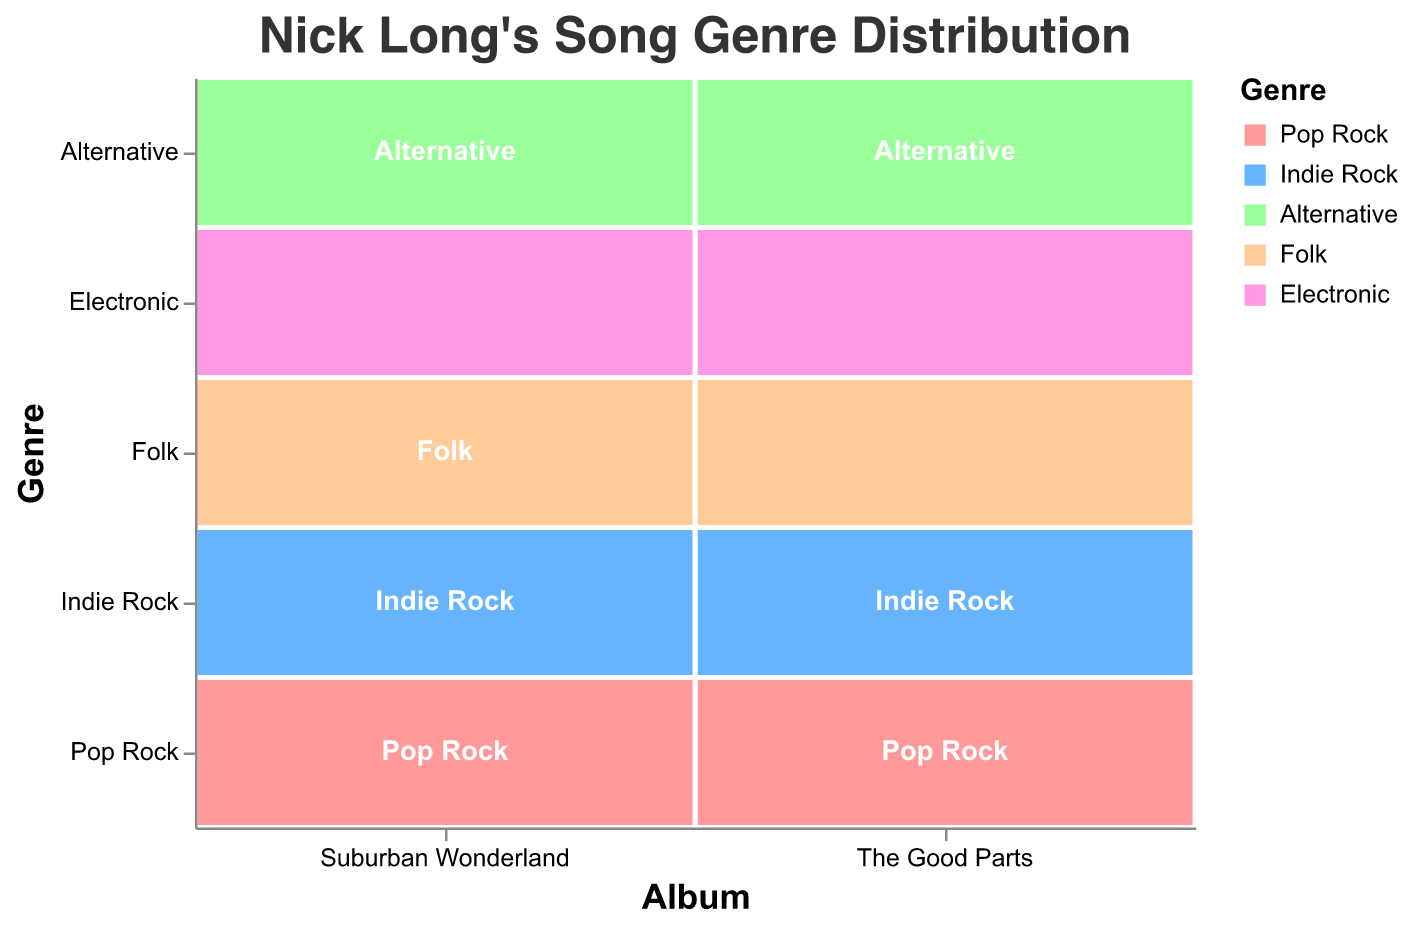What is the title of the figure? The title is text displayed at the top of the figure. In this case, it's "Nick Long's Song Genre Distribution".
Answer: Nick Long's Song Genre Distribution How many genres are represented in 'The Good Parts' album? Count the distinct genres listed under the 'Album' category for 'The Good Parts'. These genres are Pop Rock, Indie Rock, Alternative, Folk, and Electronic.
Answer: 5 Which genre has the highest count in 'Suburban Wonderland'? Look for the genre with the largest rectangle in terms of area in 'Suburban Wonderland'. 'Pop Rock' has the count of 6 which is the highest.
Answer: Pop Rock What is the total count of Folk songs across both albums? Add the Folk counts from both albums: 2 (The Good Parts) + 3 (Suburban Wonderland).
Answer: 5 Does 'Alternative' have more songs in 'The Good Parts' or 'Suburban Wonderland'? Compare the counts of 'Alternative' in both albums. 'The Good Parts' has 3 and 'Suburban Wonderland' has 5, so 'Suburban Wonderland' has more.
Answer: Suburban Wonderland What genre is least represented in both albums combined? Sum the counts for each genre across both albums and look for the smallest total. 'Electronic' has 1 (The Good Parts) + 2 (Suburban Wonderland) = 3, which is the smallest.
Answer: Electronic How many songs in total are there in 'The Good Parts'? Sum the counts for all genres in 'The Good Parts': 7 (Pop Rock) + 5 (Indie Rock) + 3 (Alternative) + 2 (Folk) + 1 (Electronic).
Answer: 18 What is the ratio of 'Pop Rock' songs in 'The Good Parts' to 'Suburban Wonderland'? Divide the count of 'Pop Rock' in 'The Good Parts' by the count in 'Suburban Wonderland': 7 / 6.
Answer: 7:6 Are there more 'Indie Rock' or 'Folk' songs in 'Suburban Wonderland'? Compare the counts of these genres in 'Suburban Wonderland': 'Indie Rock' has 4 and 'Folk' has 3, so 'Indie Rock' has more.
Answer: Indie Rock By how much does the number of 'Pop Rock' songs exceed the number of 'Electronic' songs in 'Suburban Wonderland'? Subtract the count of 'Electronic' from 'Pop Rock' in 'Suburban Wonderland': 6 - 2.
Answer: 4 